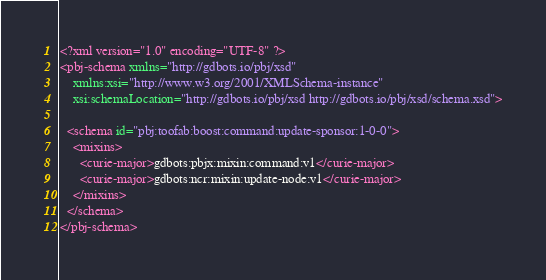Convert code to text. <code><loc_0><loc_0><loc_500><loc_500><_XML_><?xml version="1.0" encoding="UTF-8" ?>
<pbj-schema xmlns="http://gdbots.io/pbj/xsd"
    xmlns:xsi="http://www.w3.org/2001/XMLSchema-instance"
    xsi:schemaLocation="http://gdbots.io/pbj/xsd http://gdbots.io/pbj/xsd/schema.xsd">

  <schema id="pbj:toofab:boost:command:update-sponsor:1-0-0">
    <mixins>
      <curie-major>gdbots:pbjx:mixin:command:v1</curie-major>
      <curie-major>gdbots:ncr:mixin:update-node:v1</curie-major>
    </mixins>
  </schema>
</pbj-schema>
</code> 